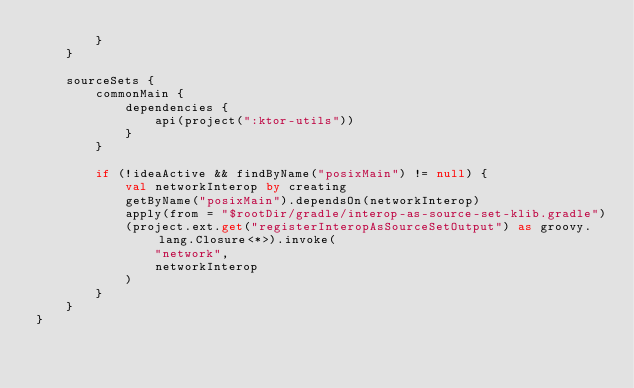Convert code to text. <code><loc_0><loc_0><loc_500><loc_500><_Kotlin_>        }
    }

    sourceSets {
        commonMain {
            dependencies {
                api(project(":ktor-utils"))
            }
        }

        if (!ideaActive && findByName("posixMain") != null) {
            val networkInterop by creating
            getByName("posixMain").dependsOn(networkInterop)
            apply(from = "$rootDir/gradle/interop-as-source-set-klib.gradle")
            (project.ext.get("registerInteropAsSourceSetOutput") as groovy.lang.Closure<*>).invoke(
                "network",
                networkInterop
            )
        }
    }
}
</code> 